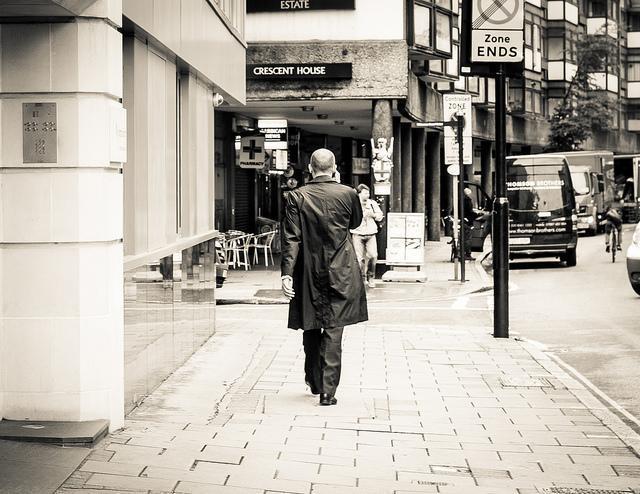How many trucks are there?
Give a very brief answer. 2. How many doors does this fridge have?
Give a very brief answer. 0. 